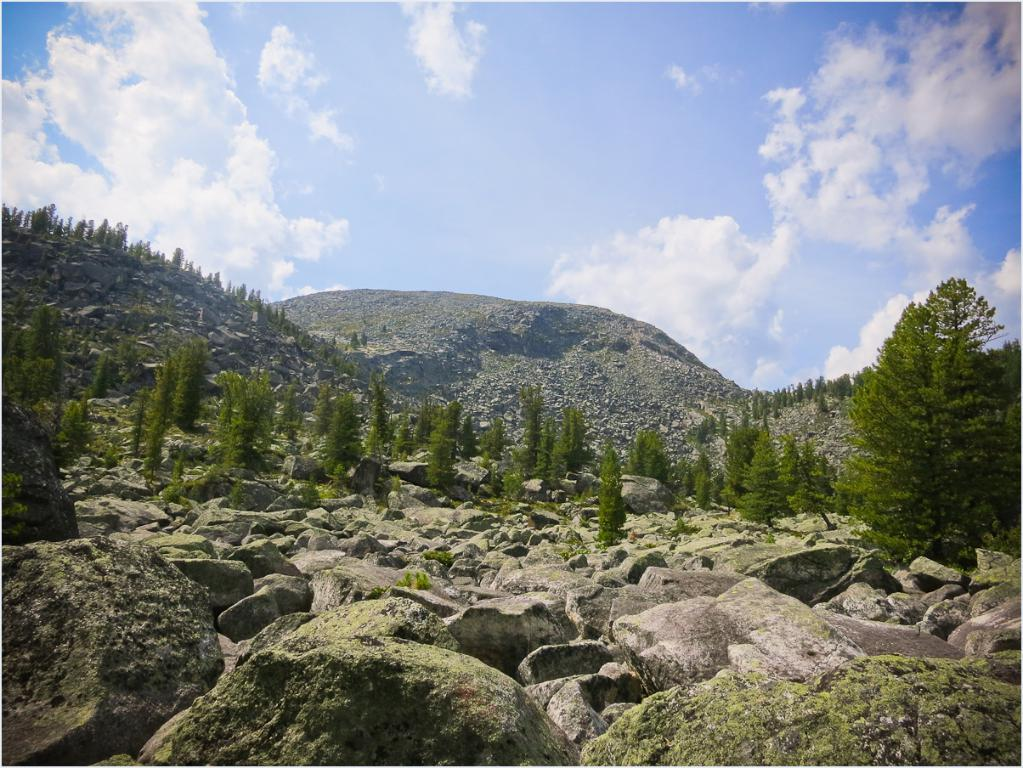What type of natural elements can be seen in the image? There are stones and trees in the image. What can be seen in the distance in the image? There are mountains visible in the background of the image. What is the weather like in the image? The sky is sunny in the background of the image. How many oranges are hanging from the trees in the image? There are no oranges present in the image; it features stones, trees, mountains, and a sunny sky. Can you describe the haircut of the person in the image? There is no person present in the image, so it is not possible to describe their haircut. 